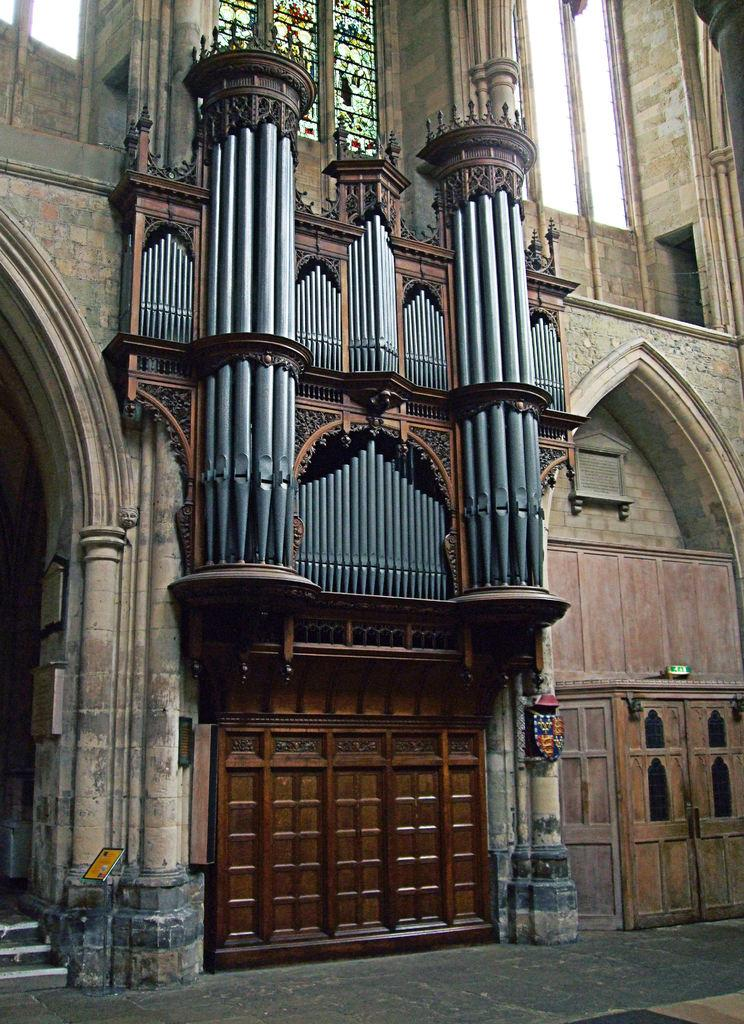What can be seen in the background of the image? There is a building in the background of the image. What is located in the middle of the image? There is furniture in the middle of the image. What type of windows are above the furniture? There are huge glass windows above the furniture. Can you tell me how many guitars are leaning against the furniture in the image? There are no guitars present in the image. What type of fork can be seen in the image? There is no fork present in the image. 